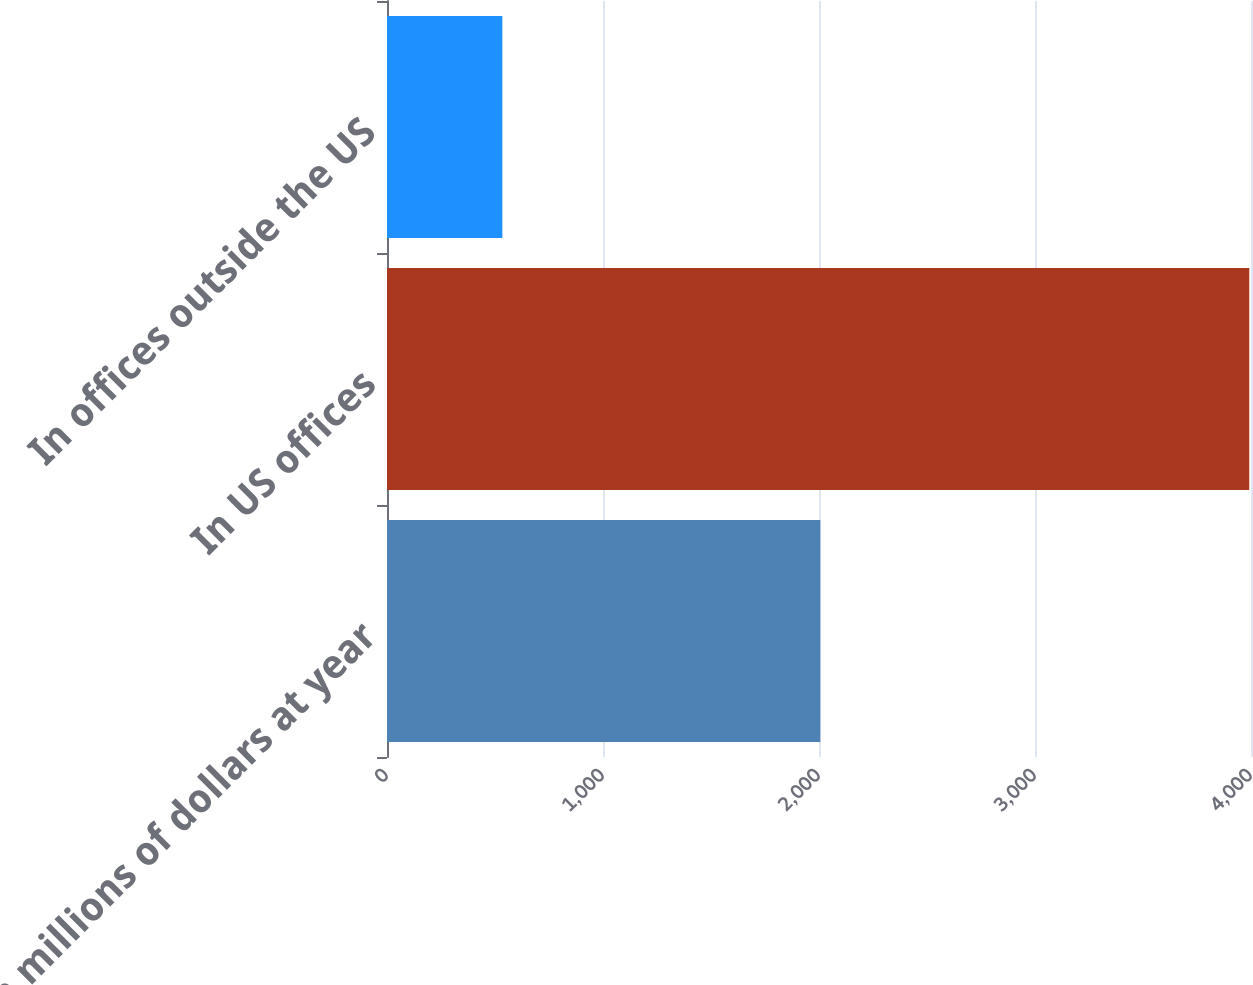Convert chart to OTSL. <chart><loc_0><loc_0><loc_500><loc_500><bar_chart><fcel>In millions of dollars at year<fcel>In US offices<fcel>In offices outside the US<nl><fcel>2006<fcel>3992<fcel>534<nl></chart> 